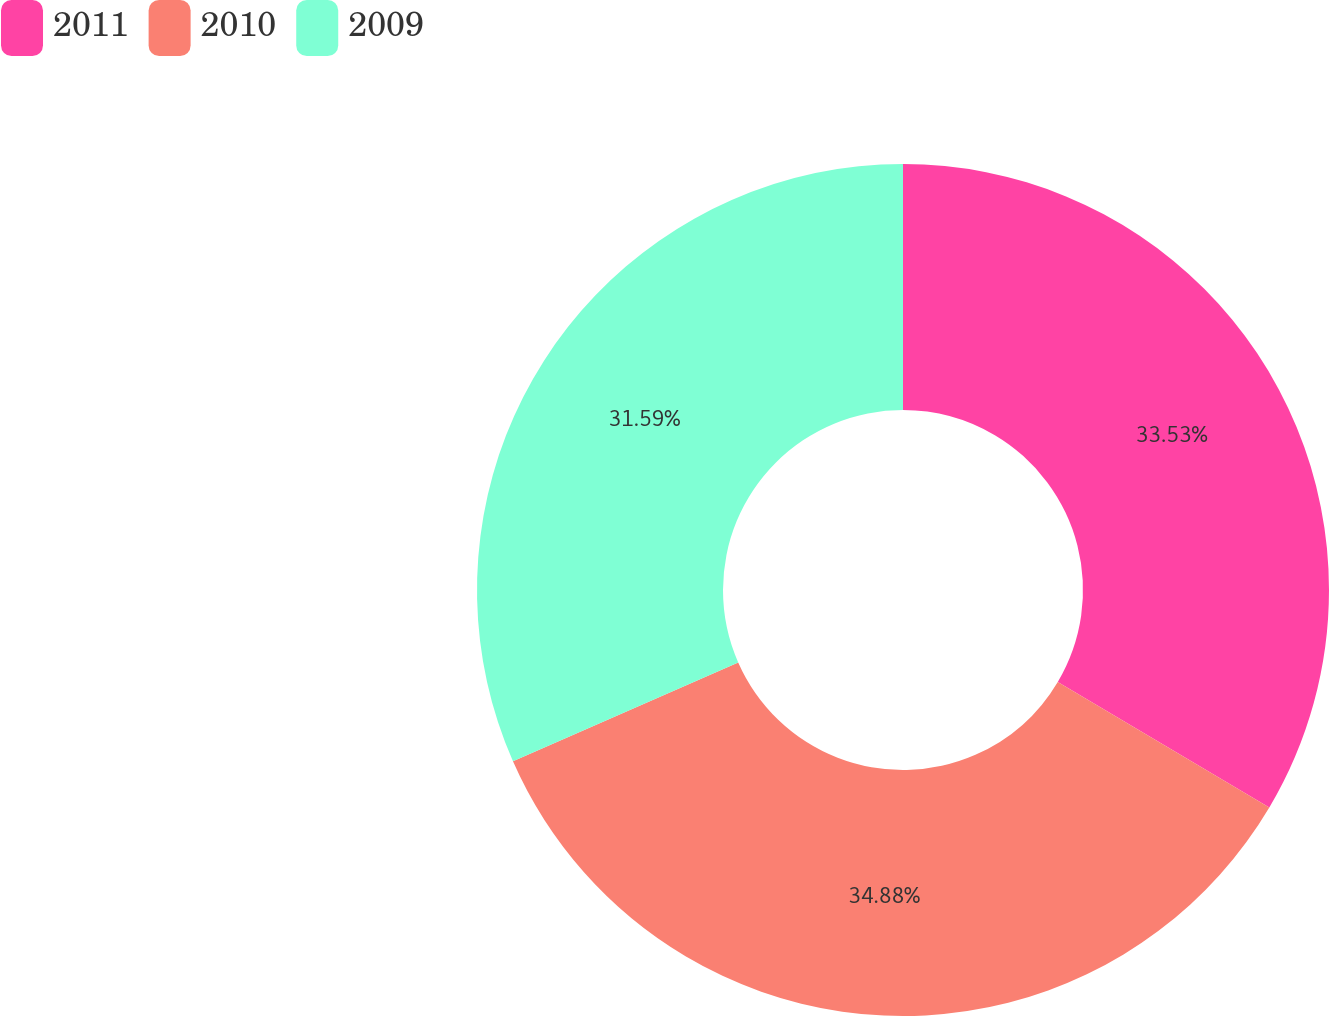<chart> <loc_0><loc_0><loc_500><loc_500><pie_chart><fcel>2011<fcel>2010<fcel>2009<nl><fcel>33.53%<fcel>34.89%<fcel>31.59%<nl></chart> 